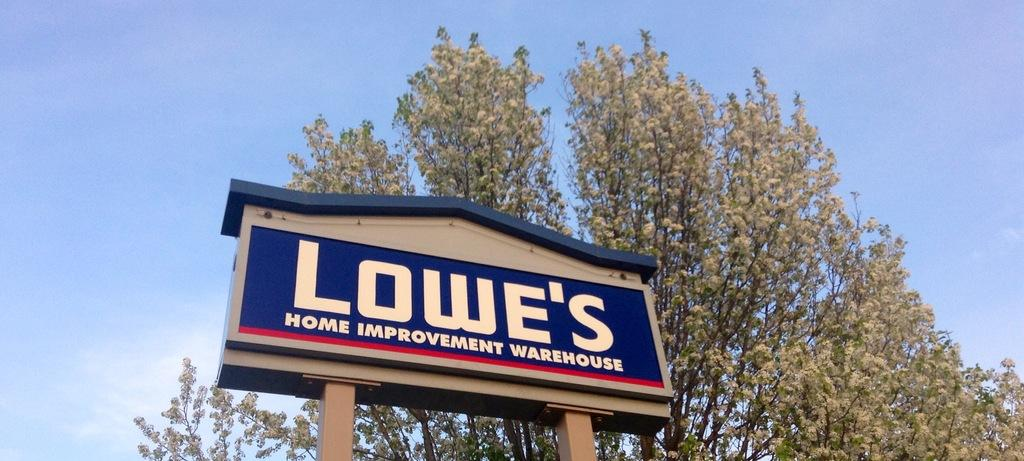What is on the pole in the image? There is a board on a pole in the image. What can be read on the board? There is text on the board. What type of vegetation is visible in the background of the image? There is a tree visible in the background of the image. What is visible at the top of the image? The sky is visible at the top of the image. What can be seen in the sky? There are clouds in the sky. What type of animal is sitting on the elbow of the person holding the board in the image? There is no person holding the board in the image, and no animal is present. 